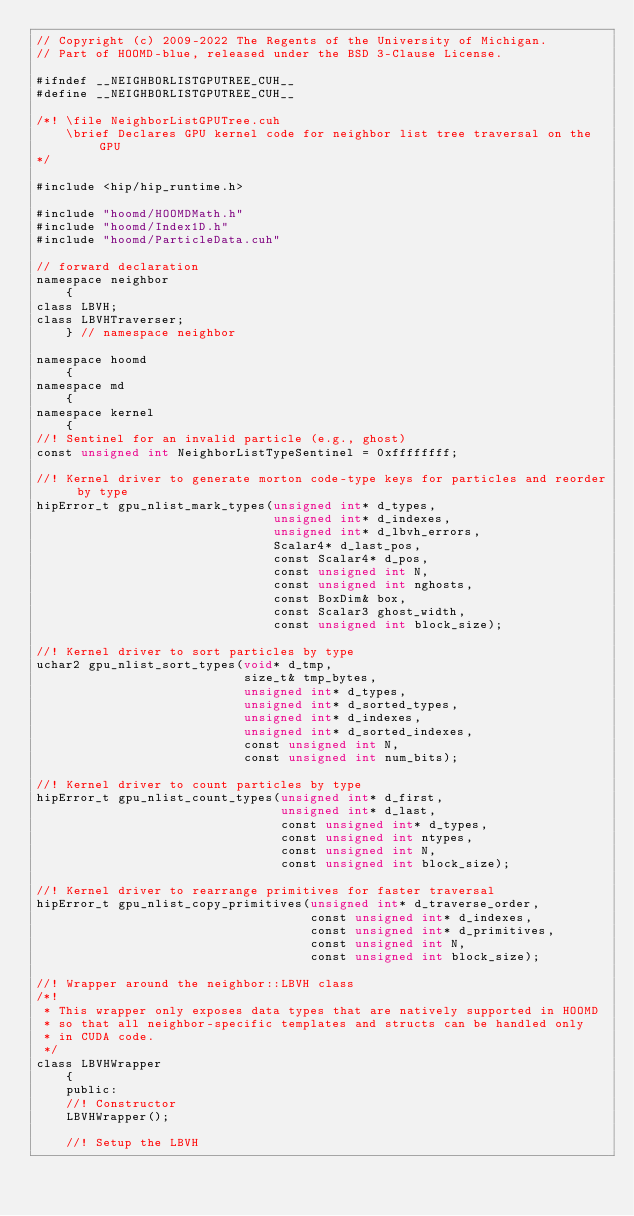Convert code to text. <code><loc_0><loc_0><loc_500><loc_500><_Cuda_>// Copyright (c) 2009-2022 The Regents of the University of Michigan.
// Part of HOOMD-blue, released under the BSD 3-Clause License.

#ifndef __NEIGHBORLISTGPUTREE_CUH__
#define __NEIGHBORLISTGPUTREE_CUH__

/*! \file NeighborListGPUTree.cuh
    \brief Declares GPU kernel code for neighbor list tree traversal on the GPU
*/

#include <hip/hip_runtime.h>

#include "hoomd/HOOMDMath.h"
#include "hoomd/Index1D.h"
#include "hoomd/ParticleData.cuh"

// forward declaration
namespace neighbor
    {
class LBVH;
class LBVHTraverser;
    } // namespace neighbor

namespace hoomd
    {
namespace md
    {
namespace kernel
    {
//! Sentinel for an invalid particle (e.g., ghost)
const unsigned int NeighborListTypeSentinel = 0xffffffff;

//! Kernel driver to generate morton code-type keys for particles and reorder by type
hipError_t gpu_nlist_mark_types(unsigned int* d_types,
                                unsigned int* d_indexes,
                                unsigned int* d_lbvh_errors,
                                Scalar4* d_last_pos,
                                const Scalar4* d_pos,
                                const unsigned int N,
                                const unsigned int nghosts,
                                const BoxDim& box,
                                const Scalar3 ghost_width,
                                const unsigned int block_size);

//! Kernel driver to sort particles by type
uchar2 gpu_nlist_sort_types(void* d_tmp,
                            size_t& tmp_bytes,
                            unsigned int* d_types,
                            unsigned int* d_sorted_types,
                            unsigned int* d_indexes,
                            unsigned int* d_sorted_indexes,
                            const unsigned int N,
                            const unsigned int num_bits);

//! Kernel driver to count particles by type
hipError_t gpu_nlist_count_types(unsigned int* d_first,
                                 unsigned int* d_last,
                                 const unsigned int* d_types,
                                 const unsigned int ntypes,
                                 const unsigned int N,
                                 const unsigned int block_size);

//! Kernel driver to rearrange primitives for faster traversal
hipError_t gpu_nlist_copy_primitives(unsigned int* d_traverse_order,
                                     const unsigned int* d_indexes,
                                     const unsigned int* d_primitives,
                                     const unsigned int N,
                                     const unsigned int block_size);

//! Wrapper around the neighbor::LBVH class
/*!
 * This wrapper only exposes data types that are natively supported in HOOMD
 * so that all neighbor-specific templates and structs can be handled only
 * in CUDA code.
 */
class LBVHWrapper
    {
    public:
    //! Constructor
    LBVHWrapper();

    //! Setup the LBVH</code> 